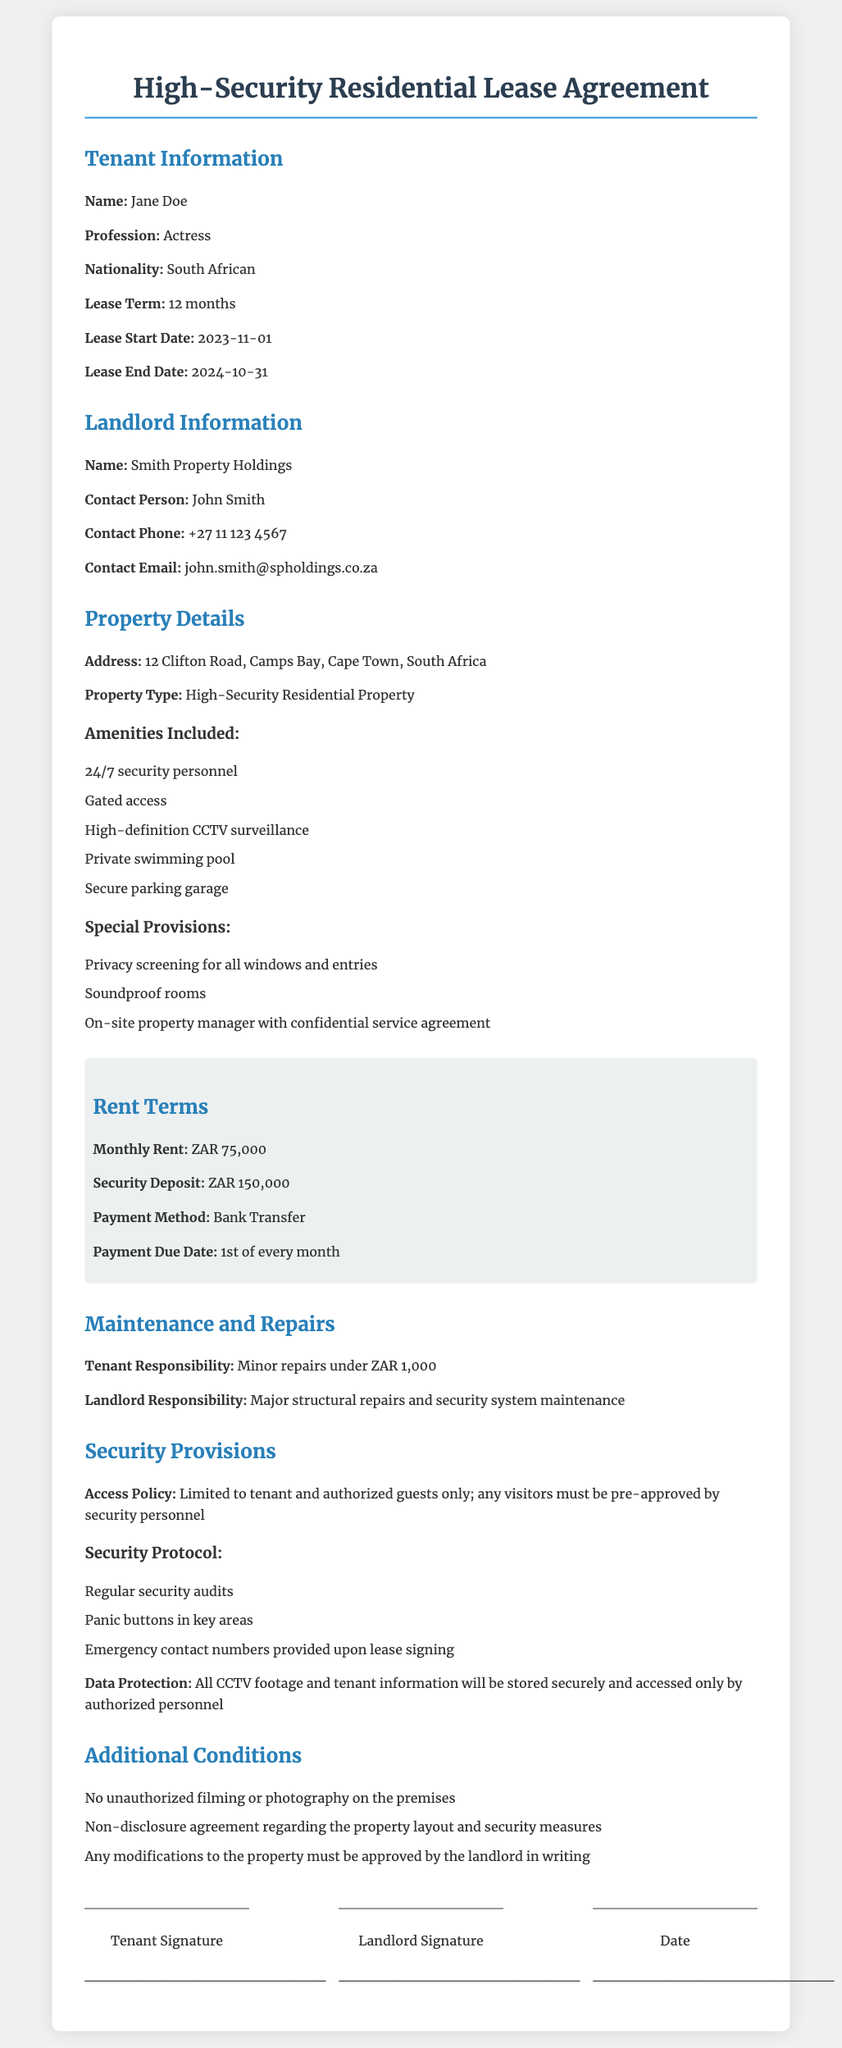What is the tenant's name? The tenant's name is listed under Tenant Information in the document.
Answer: Jane Doe What is the lease term? The lease term can be found in the Tenant Information section of the document.
Answer: 12 months What is the monthly rent? The monthly rent is specified in the Rent Terms section of the document.
Answer: ZAR 75,000 Who is the contact person for the landlord? The contact person is mentioned under Landlord Information in the document.
Answer: John Smith What security measures are included? The security measures can be found in the Security Provisions section of the document.
Answer: 24/7 security personnel, gated access, high-definition CCTV surveillance What responsibilities does the tenant have for maintenance? The tenant's maintenance responsibilities are detailed in the Maintenance and Repairs section.
Answer: Minor repairs under ZAR 1,000 What is the emergency protocol mentioned in the document? The emergency protocol can be found in the Security Protocol subsection of the Security Provisions section.
Answer: Panic buttons in key areas What type of property is being leased? The type of property is specified in the Property Details section of the document.
Answer: High-Security Residential Property What must be approved by the landlord in writing? This information is noted in the Additional Conditions section.
Answer: Any modifications to the property 